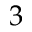<formula> <loc_0><loc_0><loc_500><loc_500>3</formula> 